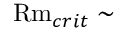<formula> <loc_0><loc_0><loc_500><loc_500>R m _ { c r i t } \sim</formula> 